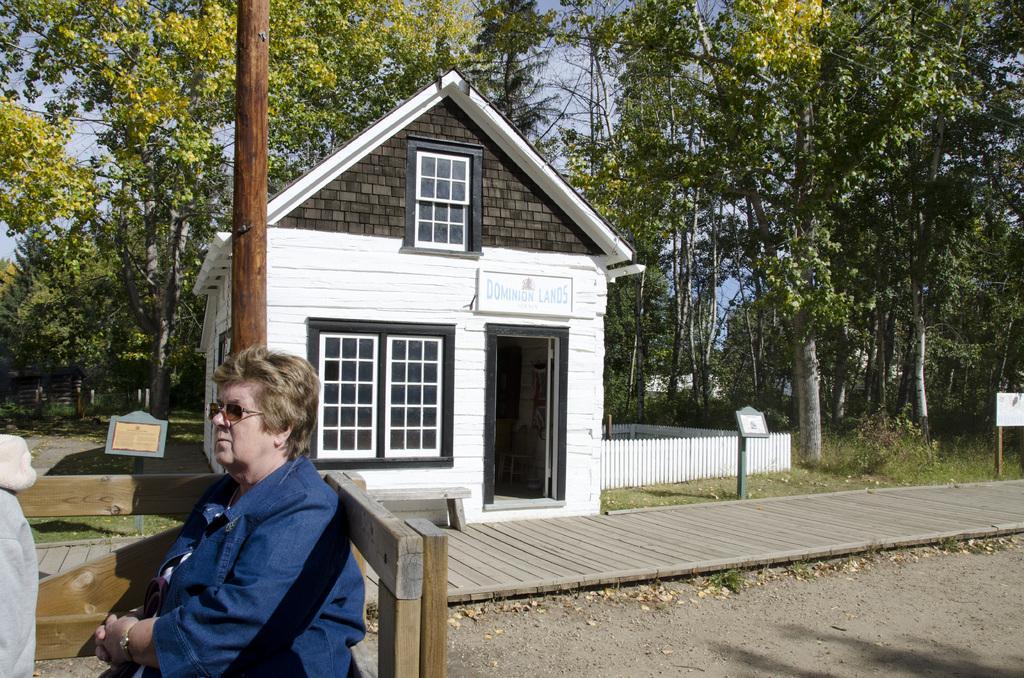Please provide a concise description of this image. In this image I can see a small house , at the top I can see the sky and tree ,in front of the house I can see a pole and I can see a woman wearing a blue color t-shirt ,sitting on the bench. 